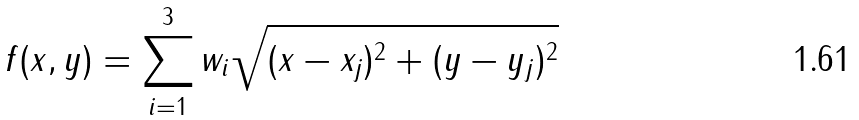<formula> <loc_0><loc_0><loc_500><loc_500>f ( x , y ) = \sum _ { i = 1 } ^ { 3 } w _ { i } \sqrt { ( x - x _ { j } ) ^ { 2 } + ( y - y _ { j } ) ^ { 2 } }</formula> 